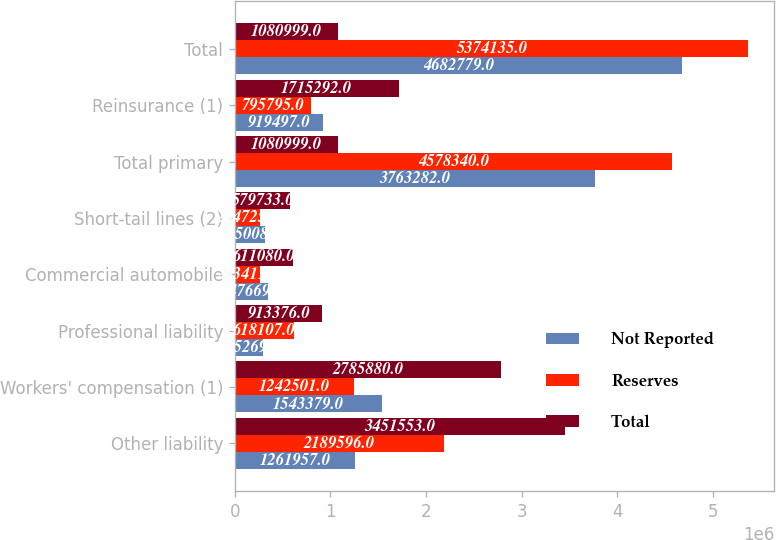<chart> <loc_0><loc_0><loc_500><loc_500><stacked_bar_chart><ecel><fcel>Other liability<fcel>Workers' compensation (1)<fcel>Professional liability<fcel>Commercial automobile<fcel>Short-tail lines (2)<fcel>Total primary<fcel>Reinsurance (1)<fcel>Total<nl><fcel>Not Reported<fcel>1.26196e+06<fcel>1.54338e+06<fcel>295269<fcel>347669<fcel>315008<fcel>3.76328e+06<fcel>919497<fcel>4.68278e+06<nl><fcel>Reserves<fcel>2.1896e+06<fcel>1.2425e+06<fcel>618107<fcel>263411<fcel>264725<fcel>4.57834e+06<fcel>795795<fcel>5.37414e+06<nl><fcel>Total<fcel>3.45155e+06<fcel>2.78588e+06<fcel>913376<fcel>611080<fcel>579733<fcel>1.081e+06<fcel>1.71529e+06<fcel>1.081e+06<nl></chart> 